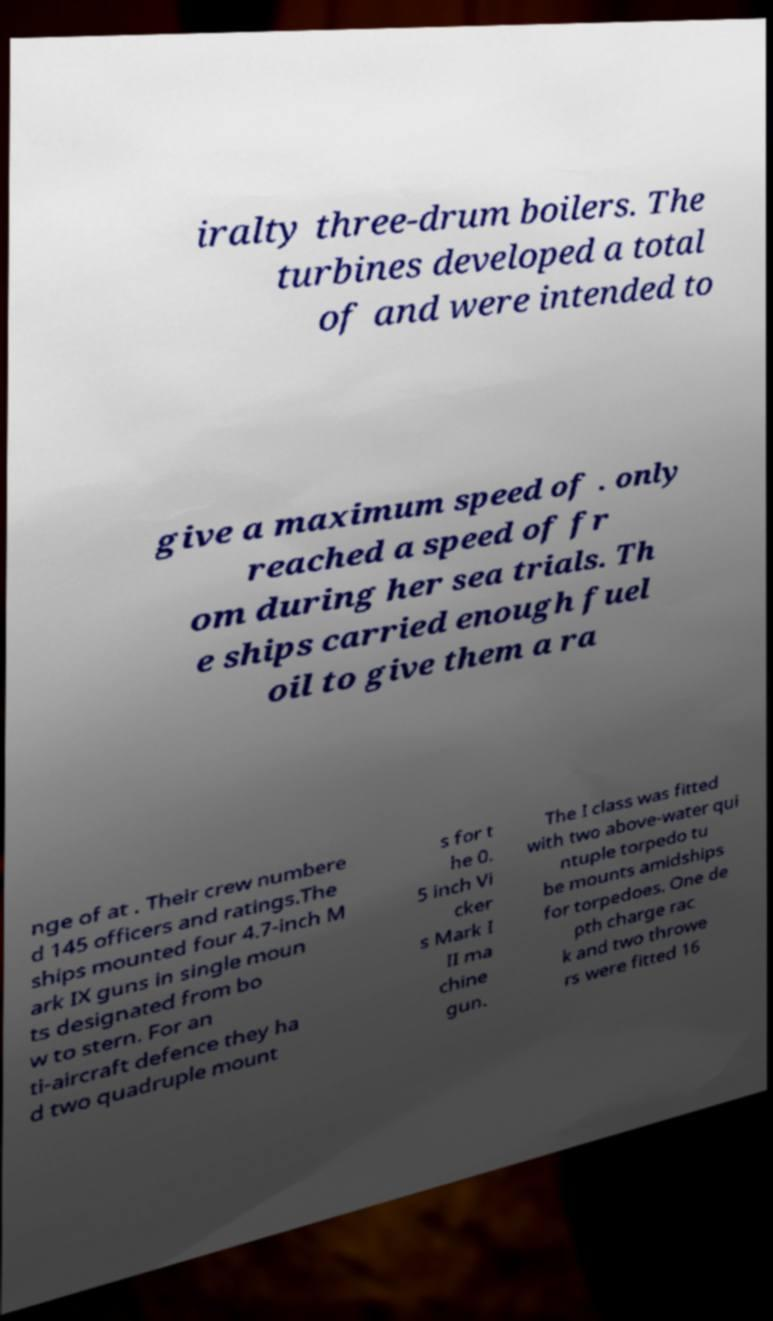Please read and relay the text visible in this image. What does it say? iralty three-drum boilers. The turbines developed a total of and were intended to give a maximum speed of . only reached a speed of fr om during her sea trials. Th e ships carried enough fuel oil to give them a ra nge of at . Their crew numbere d 145 officers and ratings.The ships mounted four 4.7-inch M ark IX guns in single moun ts designated from bo w to stern. For an ti-aircraft defence they ha d two quadruple mount s for t he 0. 5 inch Vi cker s Mark I II ma chine gun. The I class was fitted with two above-water qui ntuple torpedo tu be mounts amidships for torpedoes. One de pth charge rac k and two throwe rs were fitted 16 